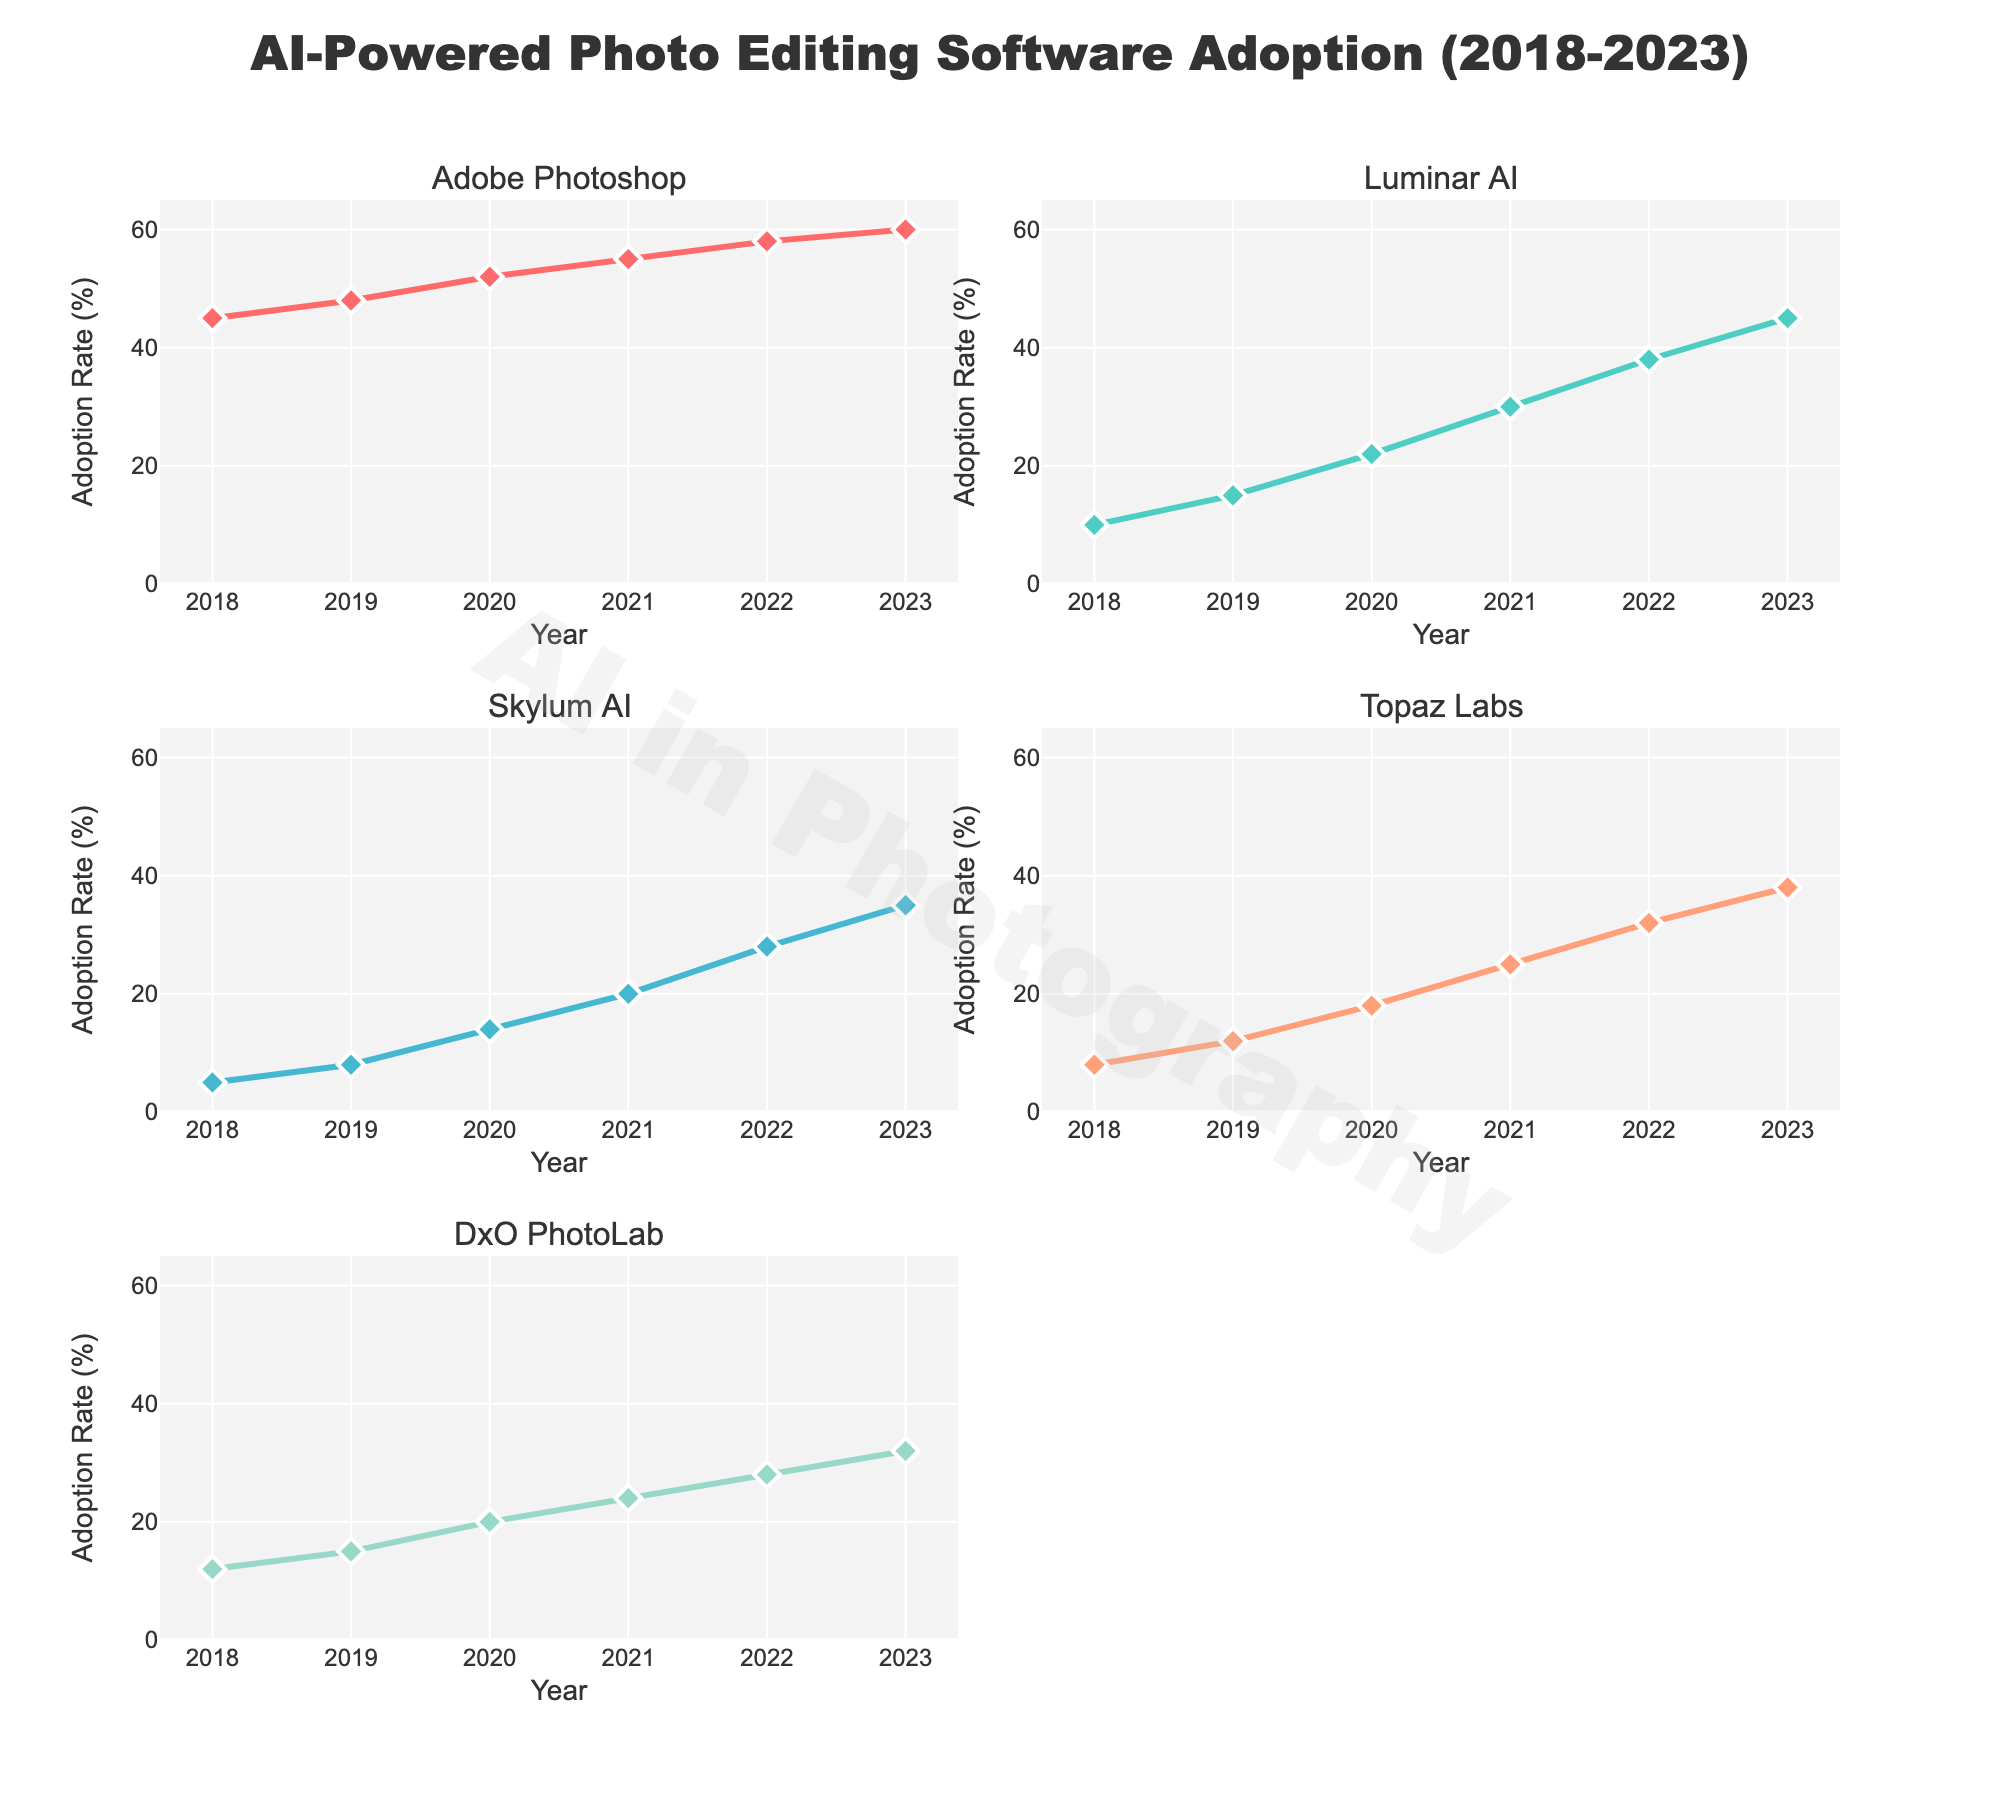What is the title of the figure? The title is located at the top-center of the figure. It reads "AI-Powered Photo Editing Software Adoption (2018-2023)".
Answer: AI-Powered Photo Editing Software Adoption (2018-2023) How many distinct software programs are compared in the figure? The subplot titles indicate each software being compared. There are five distinct software programs: Adobe Photoshop, Luminar AI, Skylum AI, Topaz Labs, and DxO PhotoLab.
Answer: Five In which year does Adobe Photoshop have the highest adoption rate? By examining the line chart for Adobe Photoshop, the adoption rate is highest in the last year shown, 2023.
Answer: 2023 What is the adoption rate for Topaz Labs in 2020? In the subplot for Topaz Labs, locate the adoption rate at the year 2020. The adoption rate is 18%.
Answer: 18% Which software shows the most significant increase in adoption rate from 2018 to 2023? Calculate the difference in adoption rates for each software between 2018 and 2023. Compare these values. The most significant increase is for Luminar AI, moving from 10% to 45%, an increase of 35%.
Answer: Luminar AI How does the adoption rate of DxO PhotoLab change from 2021 to 2023? Find the adoption rates for DxO PhotoLab in 2021 and 2023, then calculate the difference. The rate changes from 24% to 32%, an increase of 8%.
Answer: Increased by 8% Which two software programs had the same adoption rate in any given year? Examine the adoption rates across all years for each pair of software. In the year 2022, Skylum AI and Topaz Labs both had an adoption rate of 32%.
Answer: Skylum AI and Topaz Labs in 2022 Is the trend for Adobe Photoshop's adoption rate increasing or decreasing over time? Observe the line for Adobe Photoshop in the subplot. The adoption rate is consistently increasing from 45% in 2018 to 60% in 2023.
Answer: Increasing Between which years did Luminar AI experience the largest single-year increase in adoption rate? Compare the yearly differences in the adoption rates for Luminar AI. The largest increase is from 2019 to 2020, where the rate jumped from 15% to 22%.
Answer: 2019 to 2020 What is the average adoption rate of Skylum AI from 2018 to 2023? Sum the adoption rates for Skylum AI from each year (5 + 8 + 14 + 20 + 28 + 35) and divide by the number of years (6). The total is 110, so the average is 110/6.
Answer: 18.33 